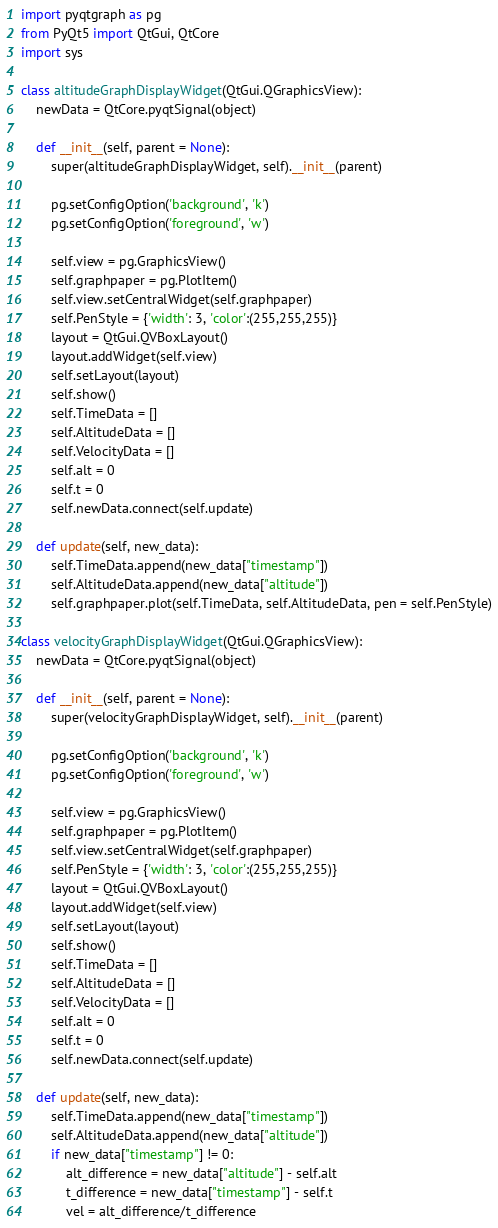<code> <loc_0><loc_0><loc_500><loc_500><_Python_>import pyqtgraph as pg
from PyQt5 import QtGui, QtCore
import sys

class altitudeGraphDisplayWidget(QtGui.QGraphicsView):
    newData = QtCore.pyqtSignal(object)

    def __init__(self, parent = None):
        super(altitudeGraphDisplayWidget, self).__init__(parent)

        pg.setConfigOption('background', 'k')
        pg.setConfigOption('foreground', 'w')

        self.view = pg.GraphicsView()
        self.graphpaper = pg.PlotItem()
        self.view.setCentralWidget(self.graphpaper)
        self.PenStyle = {'width': 3, 'color':(255,255,255)}
        layout = QtGui.QVBoxLayout()
        layout.addWidget(self.view)
        self.setLayout(layout)
        self.show()
        self.TimeData = []
        self.AltitudeData = []
        self.VelocityData = []
        self.alt = 0
        self.t = 0
        self.newData.connect(self.update)

    def update(self, new_data):
        self.TimeData.append(new_data["timestamp"])
        self.AltitudeData.append(new_data["altitude"])
        self.graphpaper.plot(self.TimeData, self.AltitudeData, pen = self.PenStyle)

class velocityGraphDisplayWidget(QtGui.QGraphicsView):
    newData = QtCore.pyqtSignal(object)

    def __init__(self, parent = None):
        super(velocityGraphDisplayWidget, self).__init__(parent)

        pg.setConfigOption('background', 'k')
        pg.setConfigOption('foreground', 'w')

        self.view = pg.GraphicsView()
        self.graphpaper = pg.PlotItem()
        self.view.setCentralWidget(self.graphpaper)
        self.PenStyle = {'width': 3, 'color':(255,255,255)}
        layout = QtGui.QVBoxLayout()
        layout.addWidget(self.view)
        self.setLayout(layout)
        self.show()
        self.TimeData = []
        self.AltitudeData = []
        self.VelocityData = []
        self.alt = 0
        self.t = 0
        self.newData.connect(self.update)

    def update(self, new_data):
        self.TimeData.append(new_data["timestamp"])
        self.AltitudeData.append(new_data["altitude"])
        if new_data["timestamp"] != 0:
            alt_difference = new_data["altitude"] - self.alt
            t_difference = new_data["timestamp"] - self.t
            vel = alt_difference/t_difference</code> 